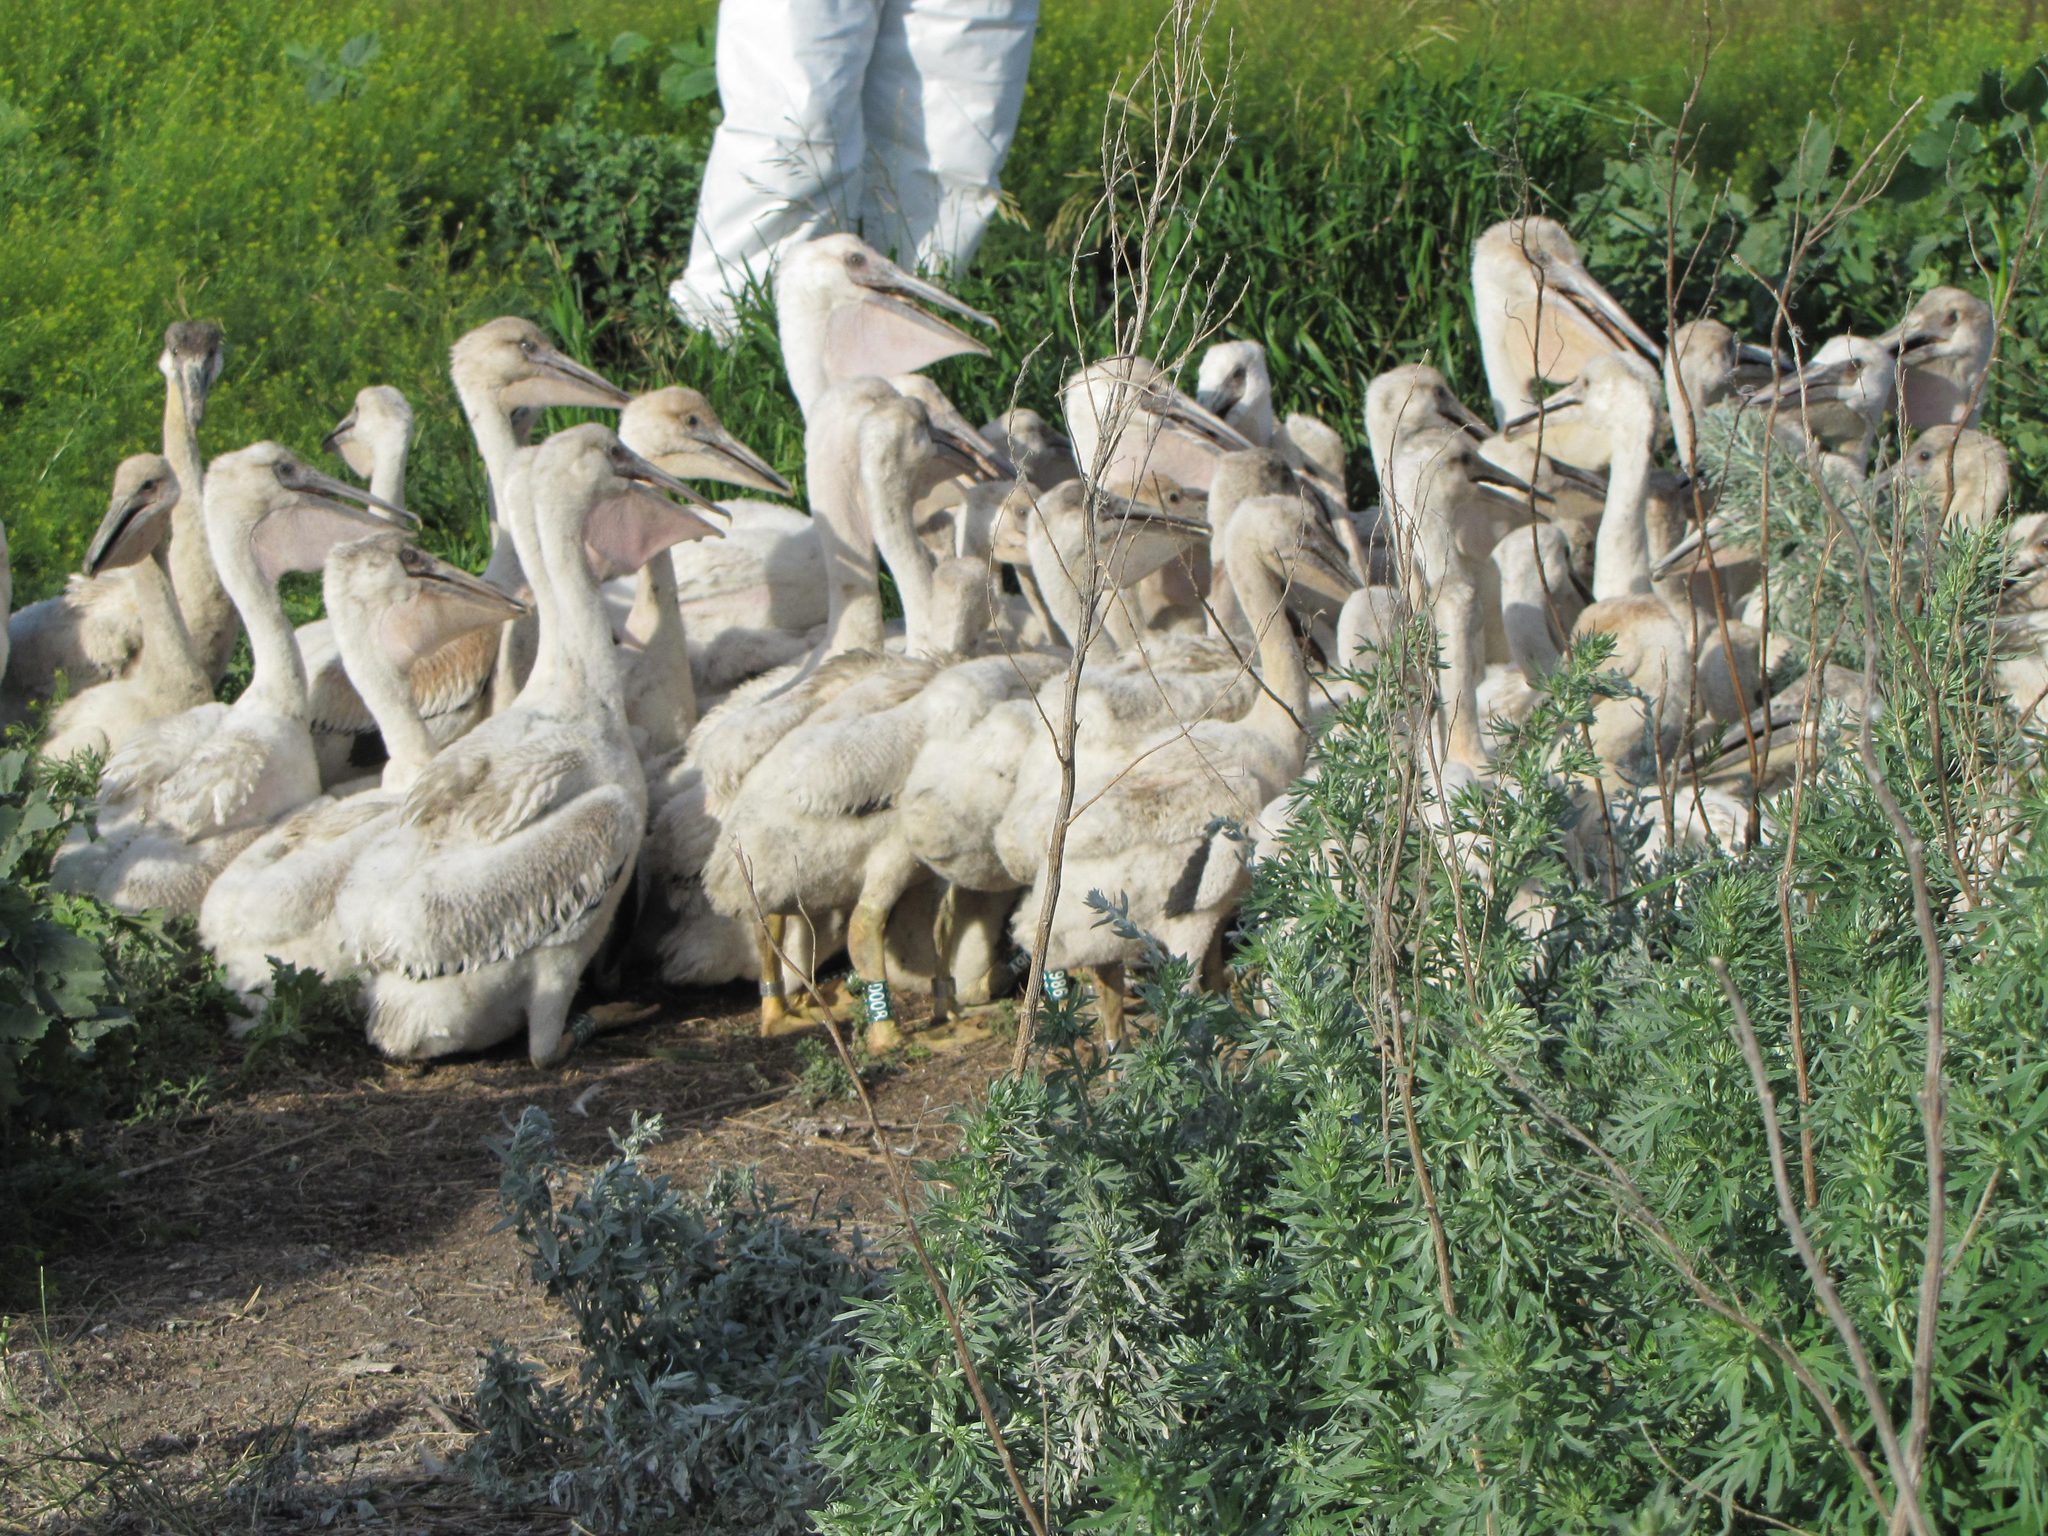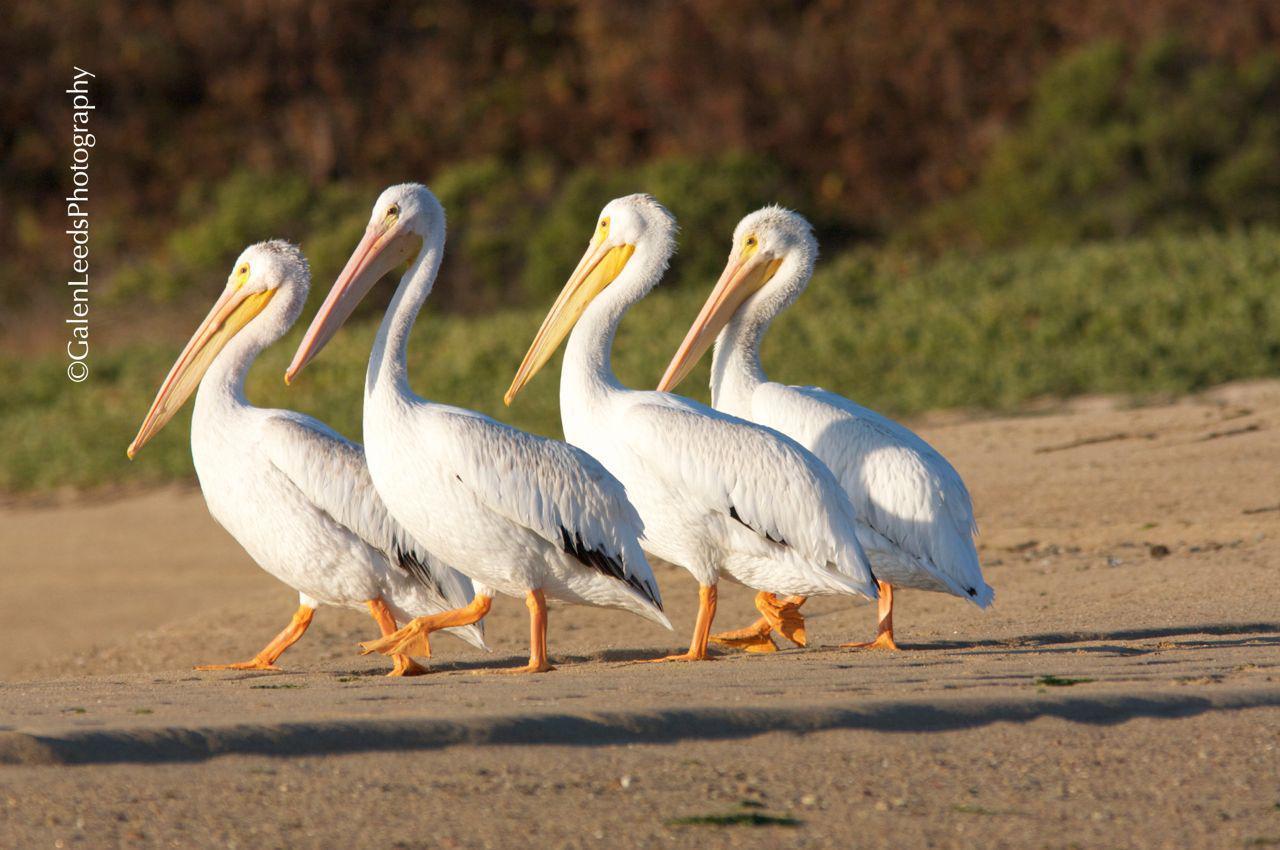The first image is the image on the left, the second image is the image on the right. Considering the images on both sides, is "One of the images shows an animal with the birds." valid? Answer yes or no. No. 